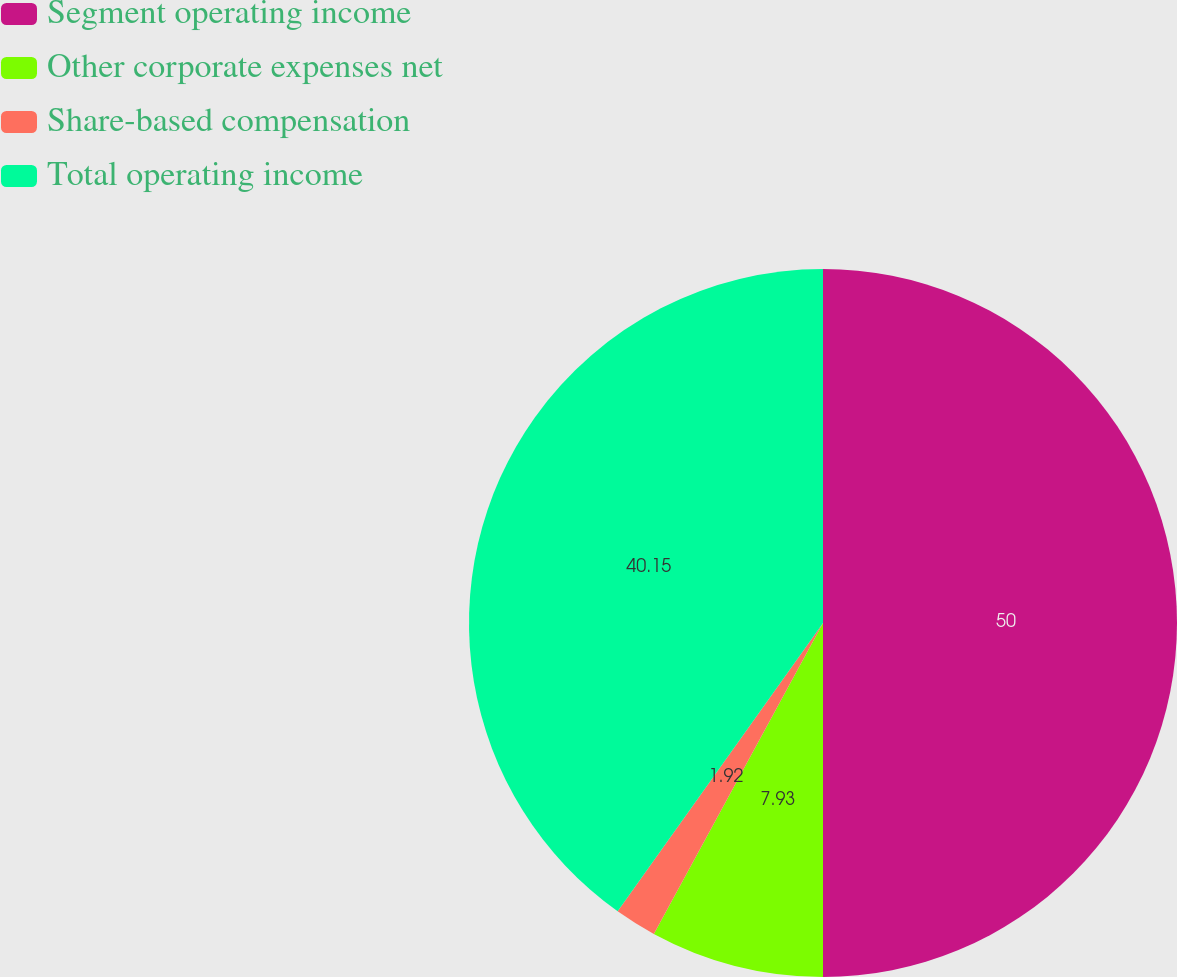<chart> <loc_0><loc_0><loc_500><loc_500><pie_chart><fcel>Segment operating income<fcel>Other corporate expenses net<fcel>Share-based compensation<fcel>Total operating income<nl><fcel>50.0%<fcel>7.93%<fcel>1.92%<fcel>40.15%<nl></chart> 